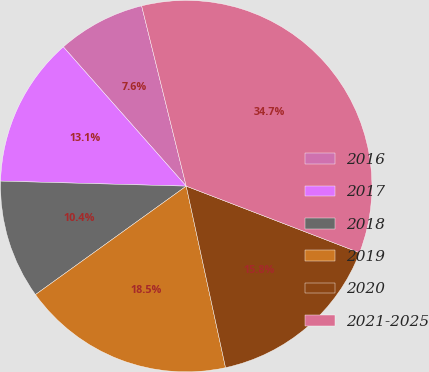Convert chart to OTSL. <chart><loc_0><loc_0><loc_500><loc_500><pie_chart><fcel>2016<fcel>2017<fcel>2018<fcel>2019<fcel>2020<fcel>2021-2025<nl><fcel>7.65%<fcel>13.06%<fcel>10.36%<fcel>18.47%<fcel>15.77%<fcel>34.7%<nl></chart> 